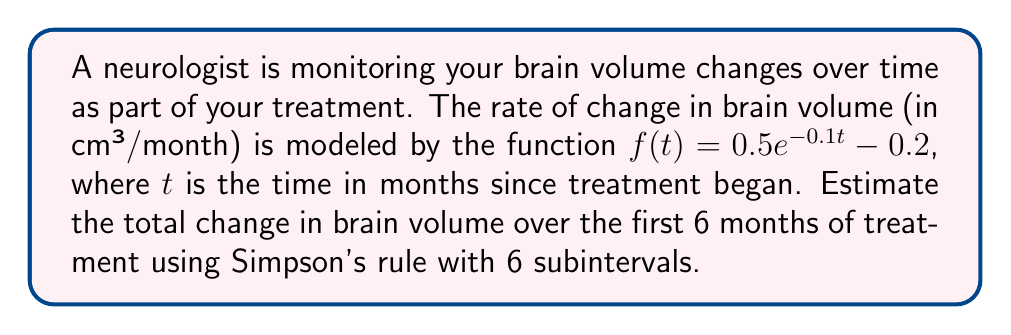Solve this math problem. 1) Simpson's rule for numerical integration is given by:

   $$\int_{a}^{b} f(x) dx \approx \frac{h}{3}[f(x_0) + 4f(x_1) + 2f(x_2) + 4f(x_3) + 2f(x_4) + 4f(x_5) + f(x_6)]$$

   where $h = \frac{b-a}{n}$, and $n$ is the number of subintervals (must be even).

2) In this case, $a=0$, $b=6$, and $n=6$. So, $h = \frac{6-0}{6} = 1$.

3) We need to calculate $f(t)$ at $t = 0, 1, 2, 3, 4, 5, 6$:

   $f(0) = 0.5e^{-0.1(0)} - 0.2 = 0.3$
   $f(1) = 0.5e^{-0.1(1)} - 0.2 \approx 0.2715$
   $f(2) = 0.5e^{-0.1(2)} - 0.2 \approx 0.2454$
   $f(3) = 0.5e^{-0.1(3)} - 0.2 \approx 0.2216$
   $f(4) = 0.5e^{-0.1(4)} - 0.2 \approx 0.1999$
   $f(5) = 0.5e^{-0.1(5)} - 0.2 \approx 0.1803$
   $f(6) = 0.5e^{-0.1(6)} - 0.2 \approx 0.1625$

4) Applying Simpson's rule:

   $$\begin{align*}
   \text{Change} &\approx \frac{1}{3}[0.3 + 4(0.2715) + 2(0.2454) + 4(0.2216) + 2(0.1999) + 4(0.1803) + 0.1625] \\
   &\approx \frac{1}{3}[0.3 + 1.0860 + 0.4908 + 0.8864 + 0.3998 + 0.7212 + 0.1625] \\
   &\approx \frac{1}{3}[4.0467] \\
   &\approx 1.3489 \text{ cm³}
   \end{align*}$$

5) Therefore, the estimated total change in brain volume over the first 6 months is approximately 1.3489 cm³.
Answer: 1.3489 cm³ 